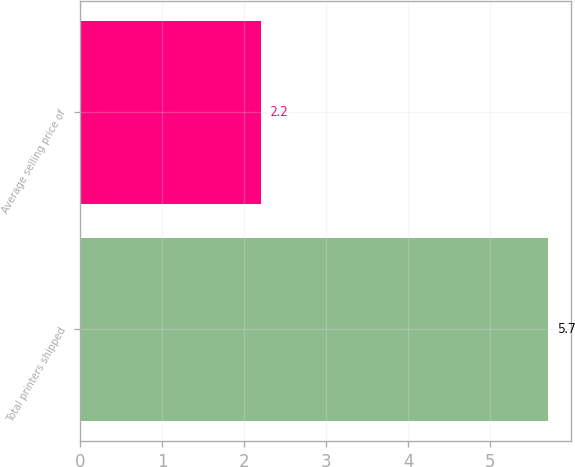<chart> <loc_0><loc_0><loc_500><loc_500><bar_chart><fcel>Total printers shipped<fcel>Average selling price of<nl><fcel>5.7<fcel>2.2<nl></chart> 